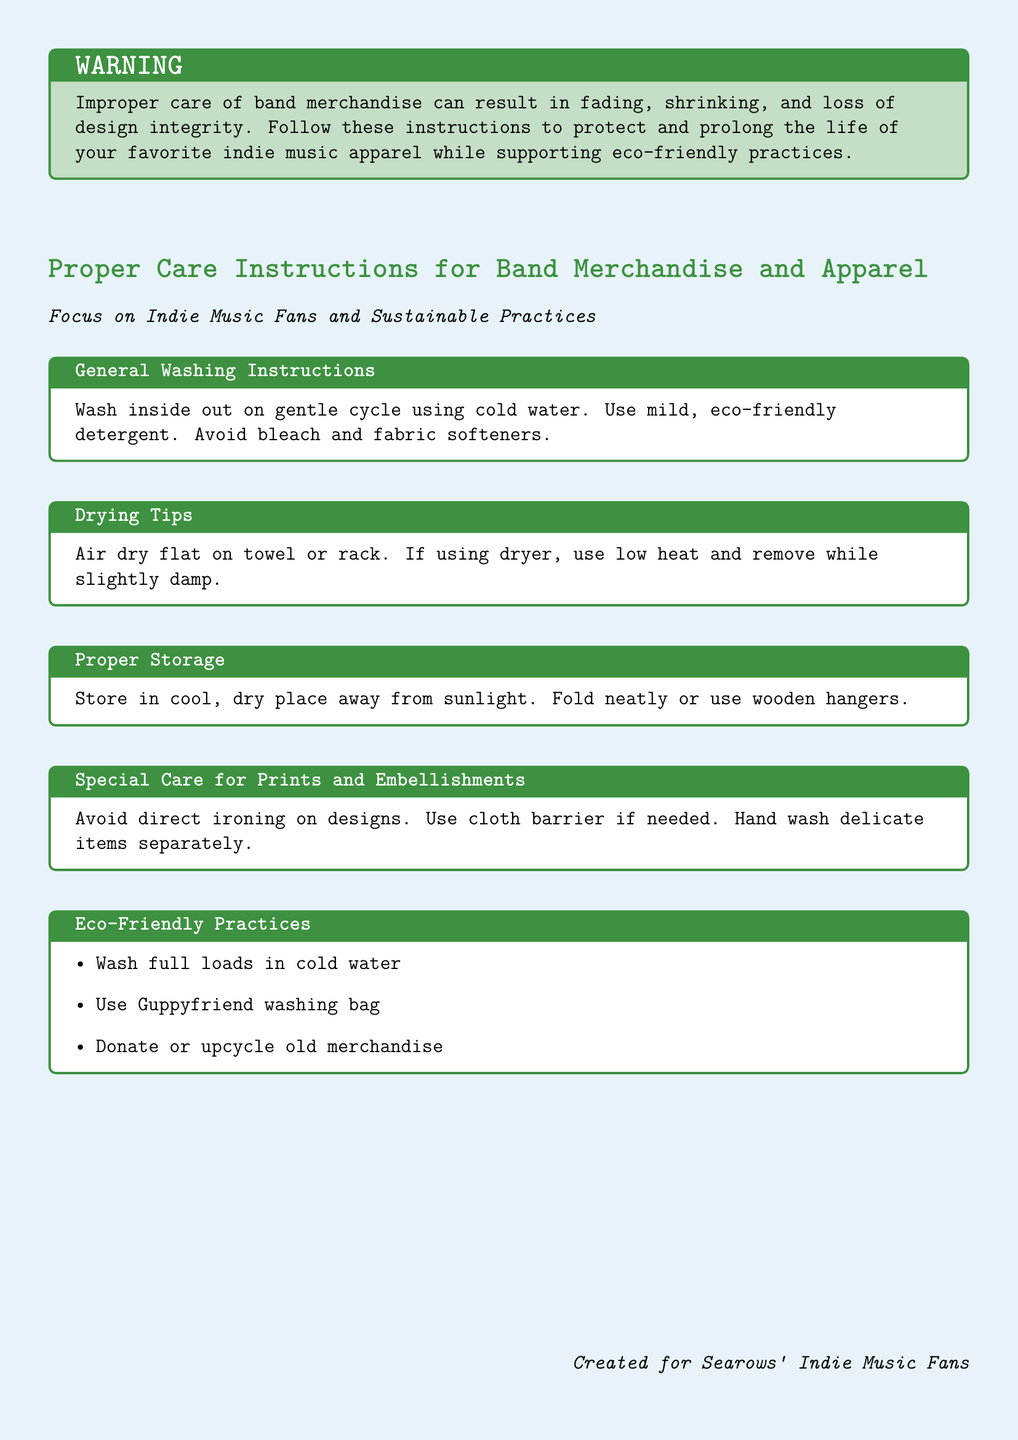What should you use to wash band merchandise? The document states to use mild, eco-friendly detergent for washing band merchandise.
Answer: eco-friendly detergent What is the recommended drying method? According to the document, the recommended method is to air dry flat on a towel or rack.
Answer: air dry flat How should band merchandise be stored? The document advises to store band merchandise in a cool, dry place away from sunlight.
Answer: cool, dry place What should be avoided when washing? The document specifies to avoid bleach and fabric softeners while washing.
Answer: bleach and fabric softeners What is one eco-friendly practice mentioned? The document lists washing full loads in cold water as an eco-friendly practice.
Answer: washing full loads in cold water Why should prints and embellishments be carefully handled? The document states to avoid direct ironing on designs to protect them from damage.
Answer: avoid direct ironing How should delicate items be washed? The document recommends hand washing delicate items separately.
Answer: hand wash separately What type of hanger is suggested for storage? The document suggests using wooden hangers for storing merchandise.
Answer: wooden hangers What is the color of the warning box? The warning box is colored with an indie-themed green shade (indie!30).
Answer: indie!30 